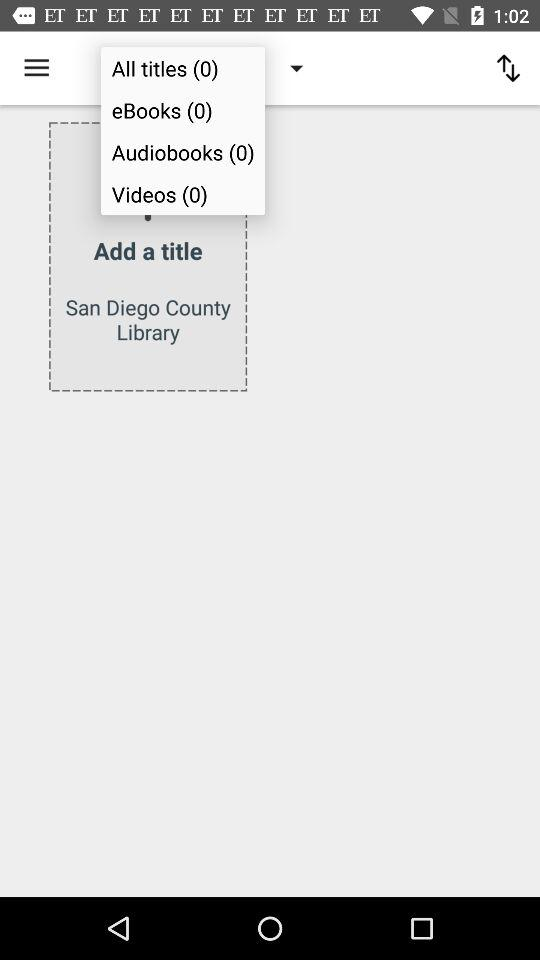What is the count of the videos? The count of the videos is 0. 